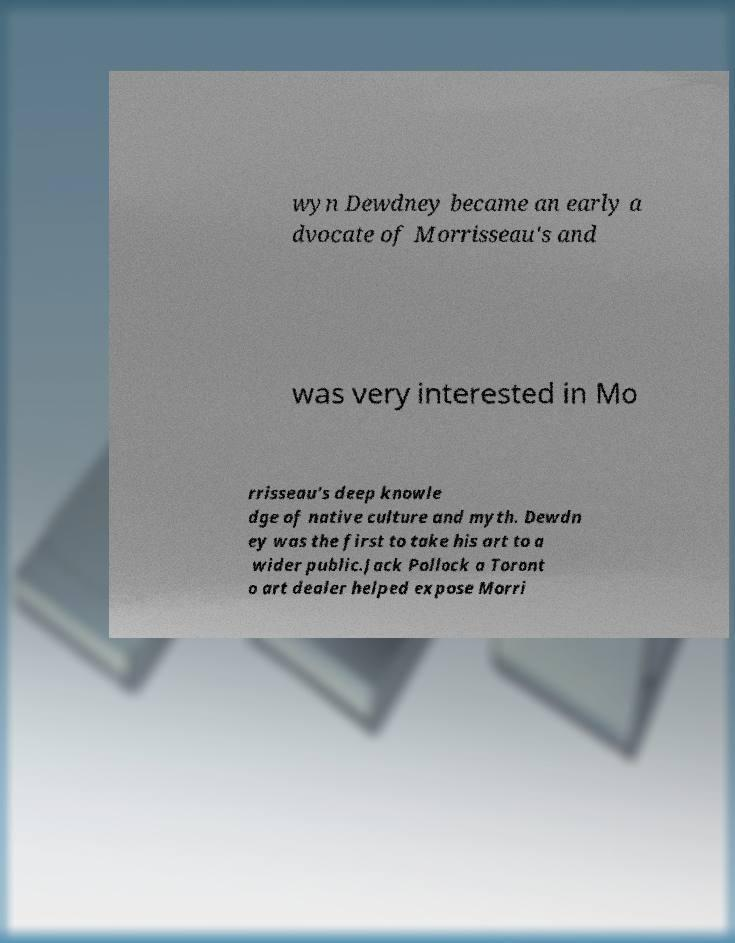Can you read and provide the text displayed in the image?This photo seems to have some interesting text. Can you extract and type it out for me? wyn Dewdney became an early a dvocate of Morrisseau's and was very interested in Mo rrisseau's deep knowle dge of native culture and myth. Dewdn ey was the first to take his art to a wider public.Jack Pollock a Toront o art dealer helped expose Morri 